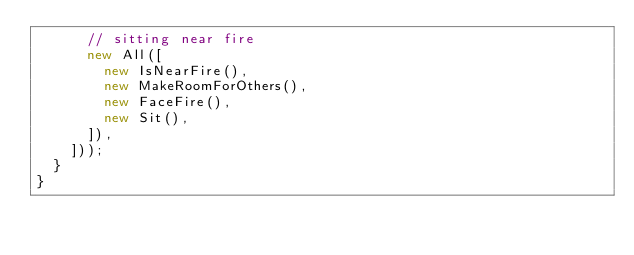<code> <loc_0><loc_0><loc_500><loc_500><_TypeScript_>      // sitting near fire
      new All([
        new IsNearFire(),
        new MakeRoomForOthers(),
        new FaceFire(),
        new Sit(),
      ]),
    ]));
  }
}
</code> 